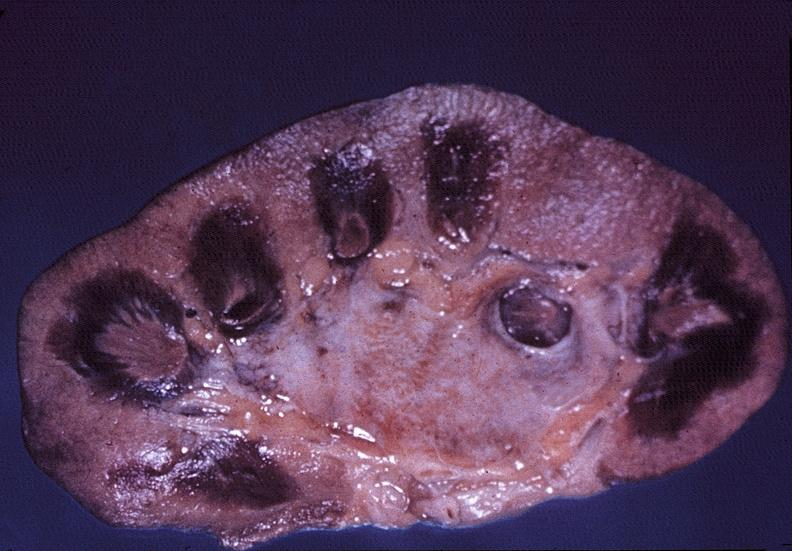s iron necrotizing?
Answer the question using a single word or phrase. No 